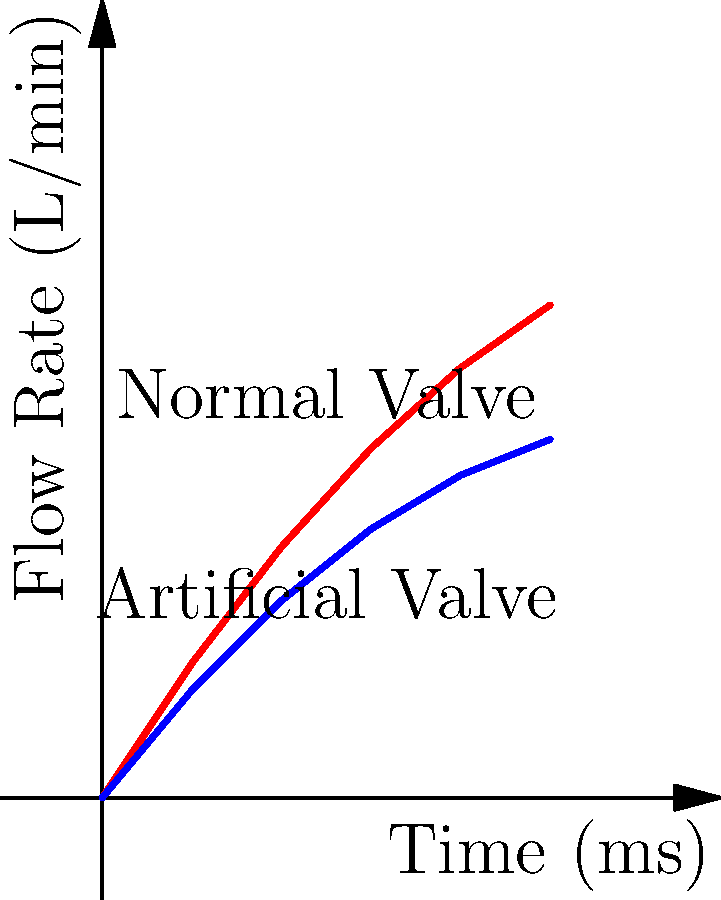As a pharmaceutical CEO developing artificial heart valves, you observe the flow rate differences between normal and artificial valves over time, as shown in the graph. If the peak flow rate for the normal valve is 5.5 L/min and the artificial valve shows a 27% reduction in peak flow, what is the Reynolds number for the artificial valve at its peak flow? Assume blood density $\rho = 1060 \text{ kg/m}^3$, viscosity $\mu = 3.5 \times 10^{-3} \text{ Pa}\cdot\text{s}$, and valve diameter $d = 2.5 \text{ cm}$. To solve this problem, let's follow these steps:

1. Calculate the peak flow rate for the artificial valve:
   $\text{Artificial peak flow} = \text{Normal peak flow} \times (1 - \text{Reduction})$
   $= 5.5 \text{ L/min} \times (1 - 0.27) = 4.015 \text{ L/min}$

2. Convert the flow rate to $\text{m}^3/\text{s}$:
   $4.015 \text{ L/min} = 4.015 \times \frac{1}{1000} \times \frac{1}{60} = 6.69167 \times 10^{-5} \text{ m}^3/\text{s}$

3. Calculate the average velocity $(v)$ using the flow rate $(Q)$ and cross-sectional area $(A)$:
   $v = \frac{Q}{A}$, where $A = \pi(\frac{d}{2})^2 = \pi(\frac{0.025}{2})^2 = 4.90874 \times 10^{-4} \text{ m}^2$
   $v = \frac{6.69167 \times 10^{-5}}{4.90874 \times 10^{-4}} = 0.13632 \text{ m/s}$

4. Use the Reynolds number formula:
   $Re = \frac{\rho vd}{\mu}$

5. Substitute the values:
   $Re = \frac{1060 \times 0.13632 \times 0.025}{3.5 \times 10^{-3}} = 1033.97$

Therefore, the Reynolds number for the artificial valve at peak flow is approximately 1034.
Answer: 1034 